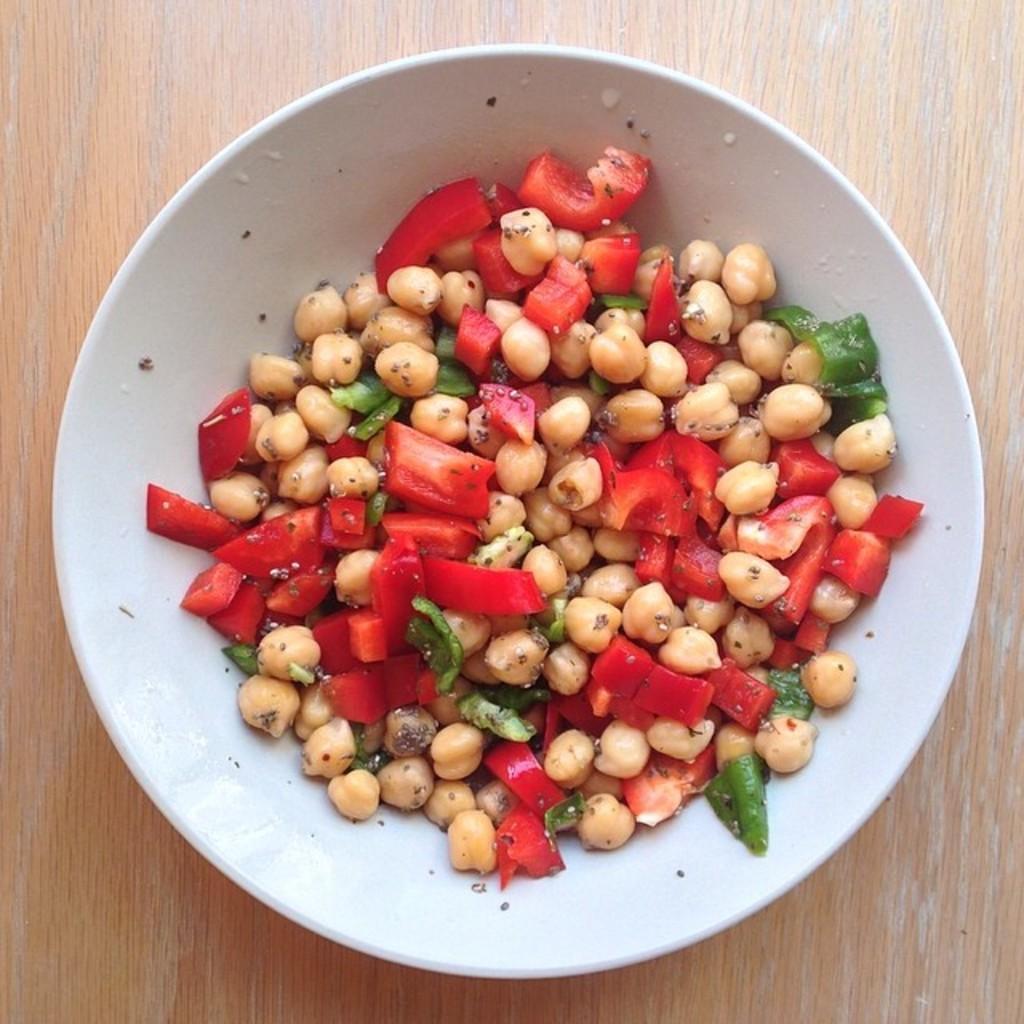Can you describe this image briefly? In this image, we can see a white color bowl and there is some food in the bowl, the bowl is on a wooden object. 